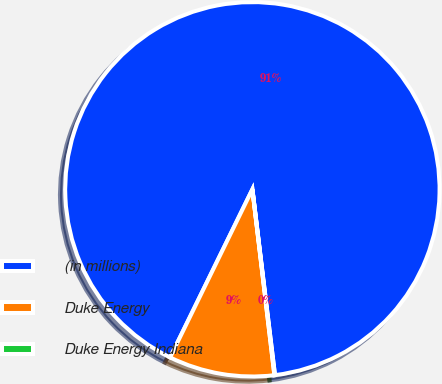Convert chart to OTSL. <chart><loc_0><loc_0><loc_500><loc_500><pie_chart><fcel>(in millions)<fcel>Duke Energy<fcel>Duke Energy Indiana<nl><fcel>90.83%<fcel>9.12%<fcel>0.05%<nl></chart> 